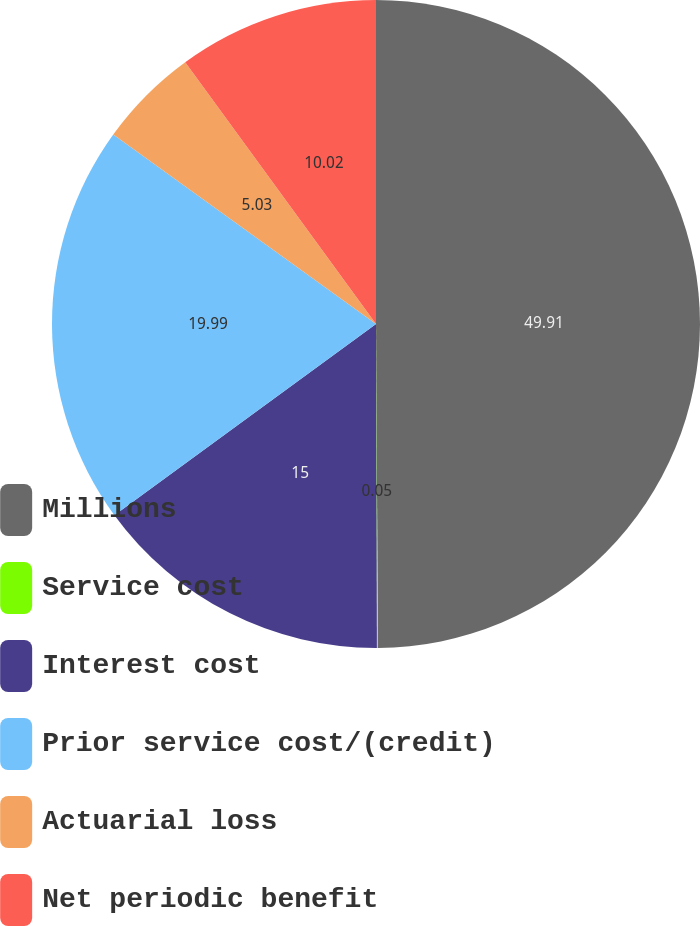<chart> <loc_0><loc_0><loc_500><loc_500><pie_chart><fcel>Millions<fcel>Service cost<fcel>Interest cost<fcel>Prior service cost/(credit)<fcel>Actuarial loss<fcel>Net periodic benefit<nl><fcel>49.9%<fcel>0.05%<fcel>15.0%<fcel>19.99%<fcel>5.03%<fcel>10.02%<nl></chart> 